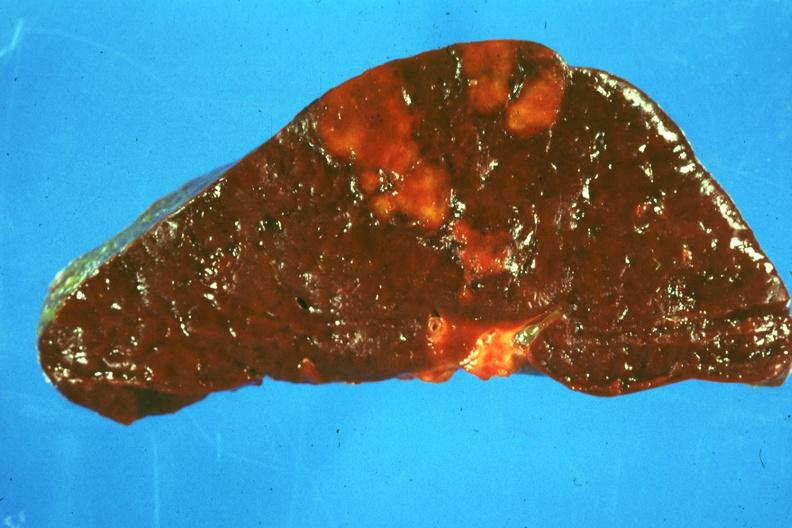s beckwith-wiedemann syndrome present?
Answer the question using a single word or phrase. No 